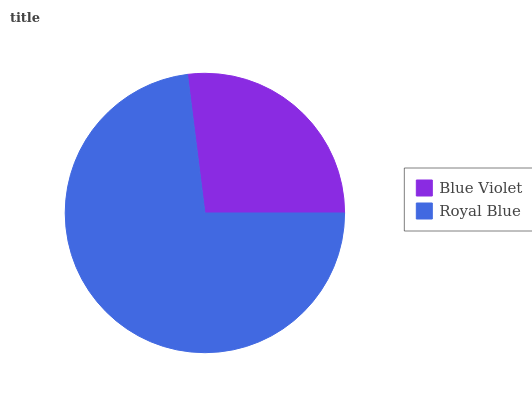Is Blue Violet the minimum?
Answer yes or no. Yes. Is Royal Blue the maximum?
Answer yes or no. Yes. Is Royal Blue the minimum?
Answer yes or no. No. Is Royal Blue greater than Blue Violet?
Answer yes or no. Yes. Is Blue Violet less than Royal Blue?
Answer yes or no. Yes. Is Blue Violet greater than Royal Blue?
Answer yes or no. No. Is Royal Blue less than Blue Violet?
Answer yes or no. No. Is Royal Blue the high median?
Answer yes or no. Yes. Is Blue Violet the low median?
Answer yes or no. Yes. Is Blue Violet the high median?
Answer yes or no. No. Is Royal Blue the low median?
Answer yes or no. No. 